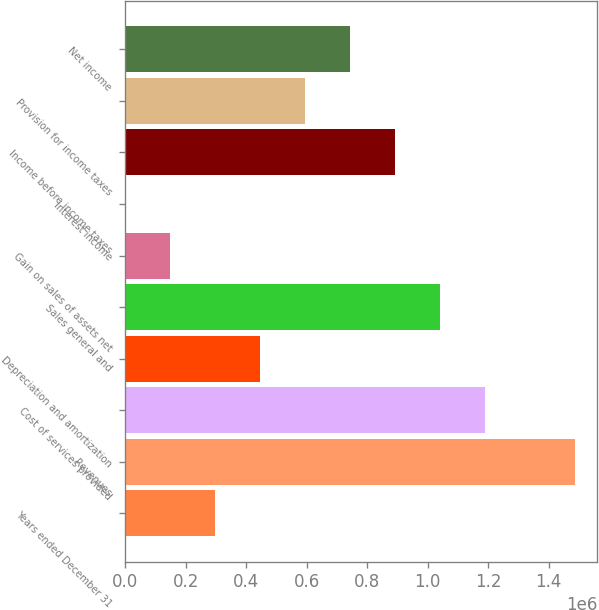Convert chart. <chart><loc_0><loc_0><loc_500><loc_500><bar_chart><fcel>Years ended December 31<fcel>Revenues<fcel>Cost of services provided<fcel>Depreciation and amortization<fcel>Sales general and<fcel>Gain on sales of assets net<fcel>Interest income<fcel>Income before income taxes<fcel>Provision for income taxes<fcel>Net income<nl><fcel>297189<fcel>1.4853e+06<fcel>1.18828e+06<fcel>445704<fcel>1.03976e+06<fcel>148674<fcel>160<fcel>891247<fcel>594218<fcel>742732<nl></chart> 